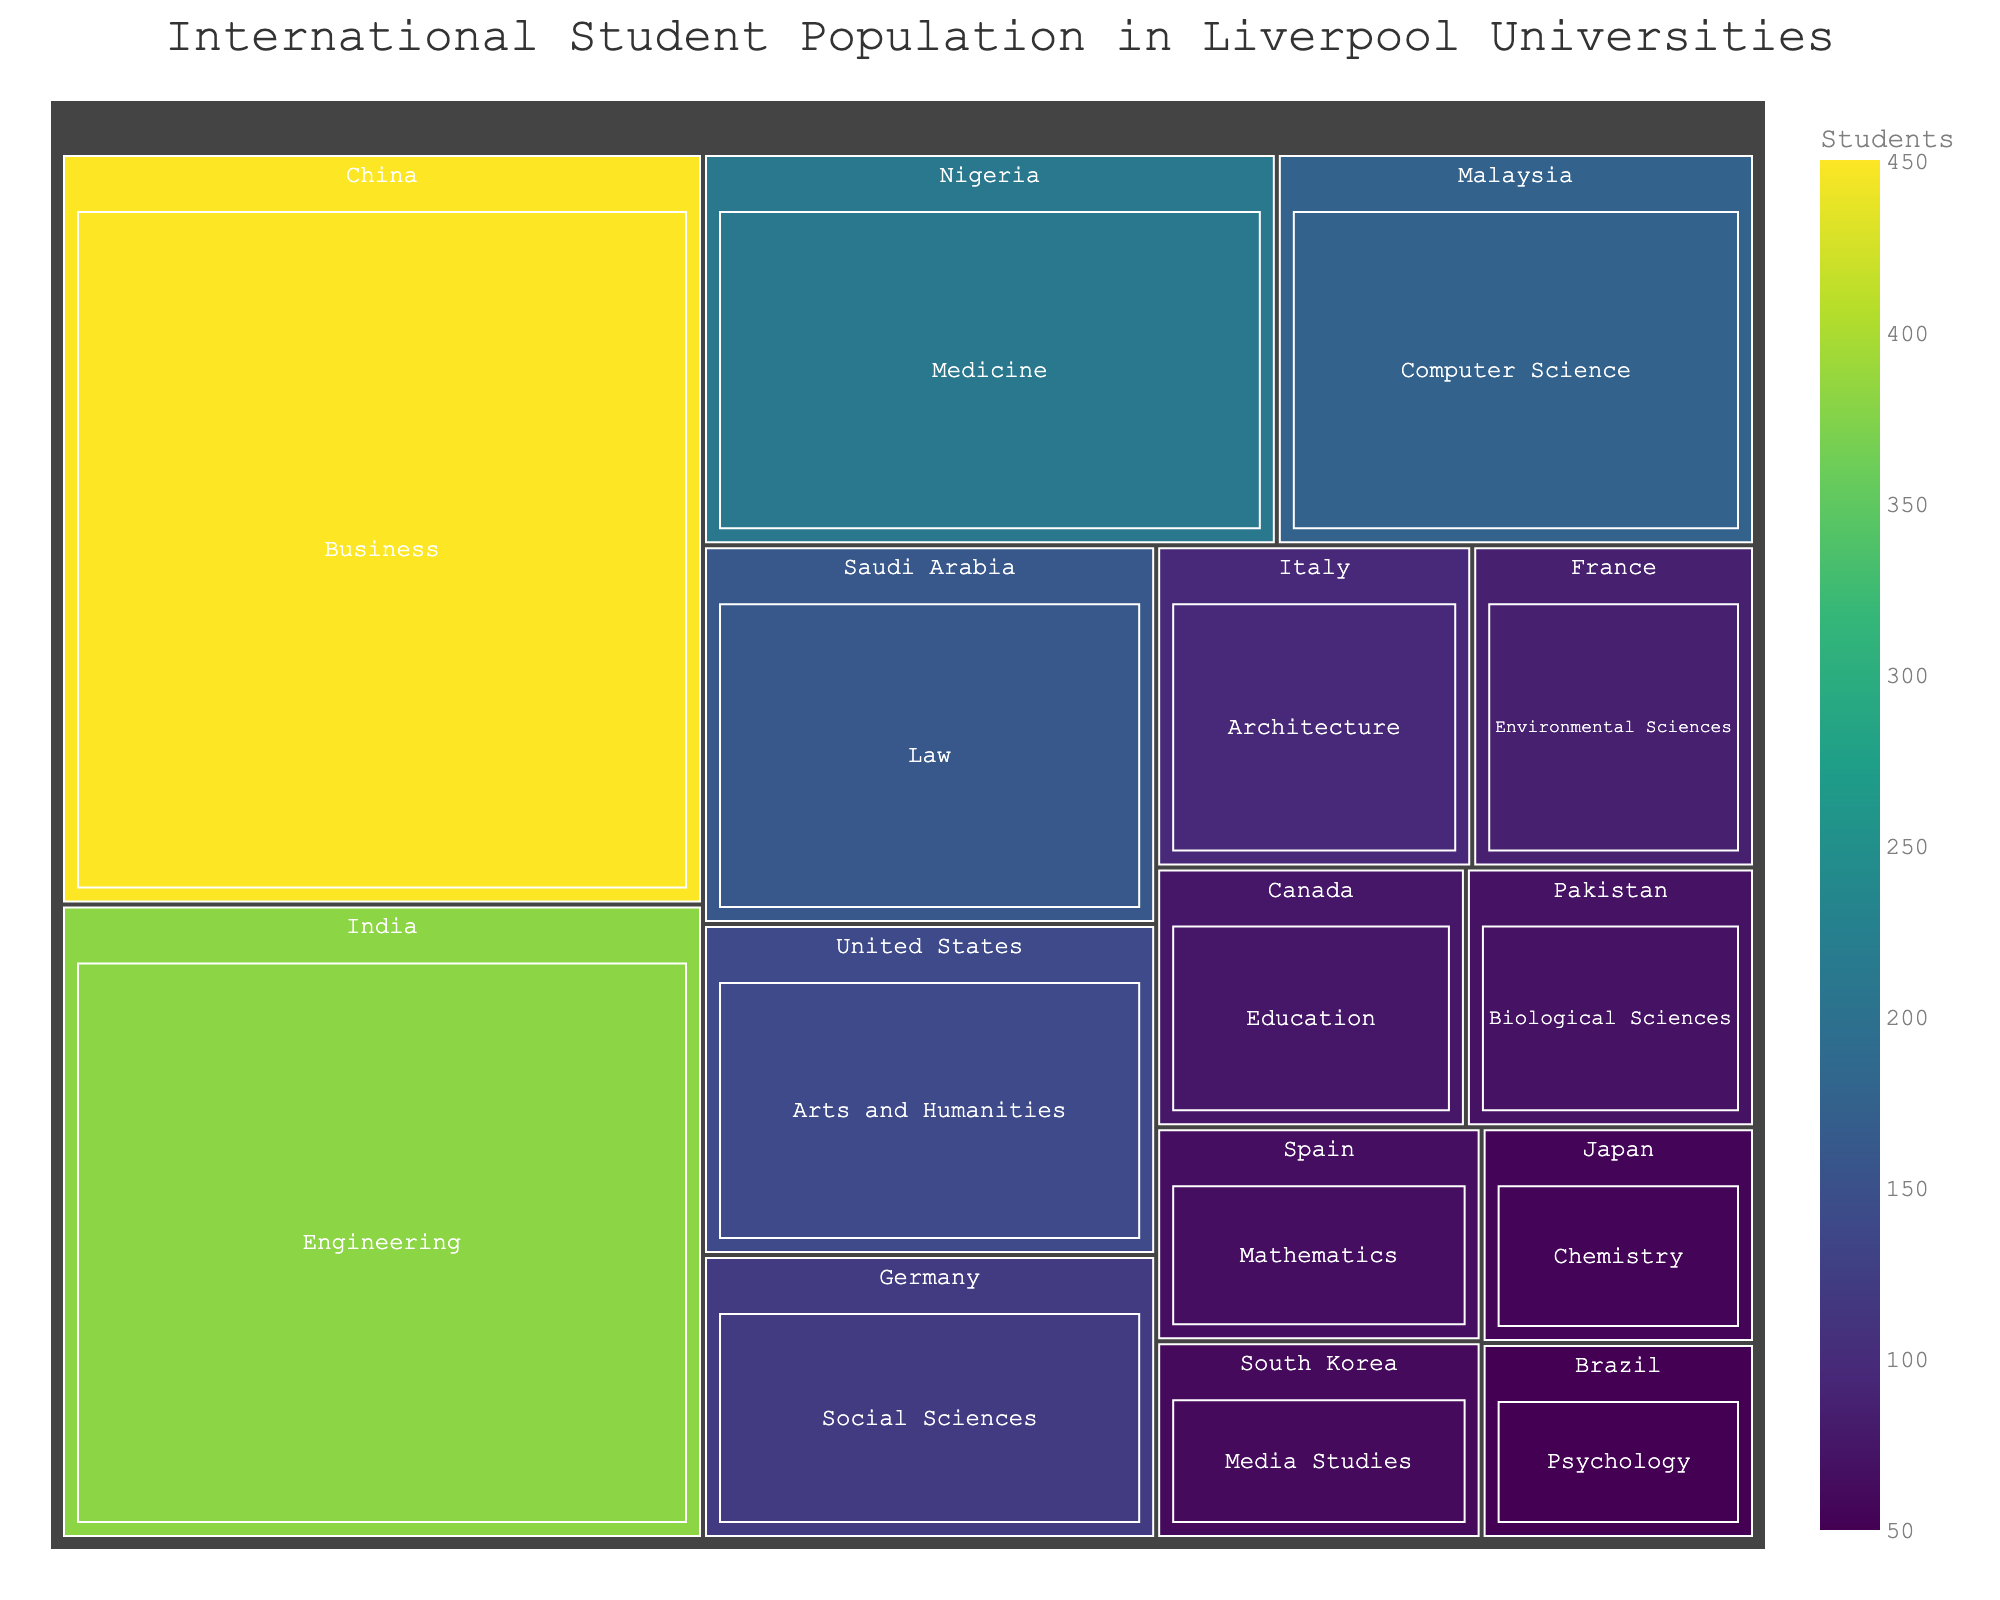What's the title of the treemap? The title of the treemap is usually displayed at the top of the figure. In this case, the title is mentioned in the code for generating the plot.
Answer: International Student Population in Liverpool Universities How many students are studying Business from China? Each rectangle in the treemap represents a combination of country and field of study, and the number of students is displayed within or next to these rectangles. Locate 'China' and 'Business' to find the student count.
Answer: 450 Which country has the highest number of students studying in Liverpool universities? The largest rectangle in the treemap represents the country with the highest number of students. By comparing the sizes, we identify China as the largest.
Answer: China What's the smallest field of study by student count among international students in Liverpool universities? Identify and compare all the smallest rectangles representing each field of study. The one with the smallest size represents the fields with the fewest students.
Answer: Psychology How many students are studying Social Sciences from Germany? Locate the rectangle for 'Germany' and look for 'Social Sciences' within that section. The number displayed corresponds to the students in Social Sciences from Germany.
Answer: 120 Compare the number of students from Nigeria and Saudi Arabia. Which country has more students, and by how many? Identify the rectangles for Nigeria and Saudi Arabia and read their student counts. Subtract the smaller count from the larger one.
Answer: Nigeria by 50 students What's the total number of students from Canada and Pakistan combined? Find the student count for both Canada and Pakistan and add them together.
Answer: 75 + 70 = 145 Which field of study has the most international students from Liverpool universities? The largest rectangle under any country's section will indicate the field of study with the most international students.
Answer: Business What is the difference in the number of students studying Engineering from India and those studying Architecture from Italy? Locate the rectangles for 'Engineering' from India and 'Architecture' from Italy, and then subtract the latter from the former.
Answer: 380 - 95 = 285 How many fields of study have fewer than 100 students? Count the number of rectangles that display a student count of fewer than 100 within all sections of the treemap.
Answer: 7 